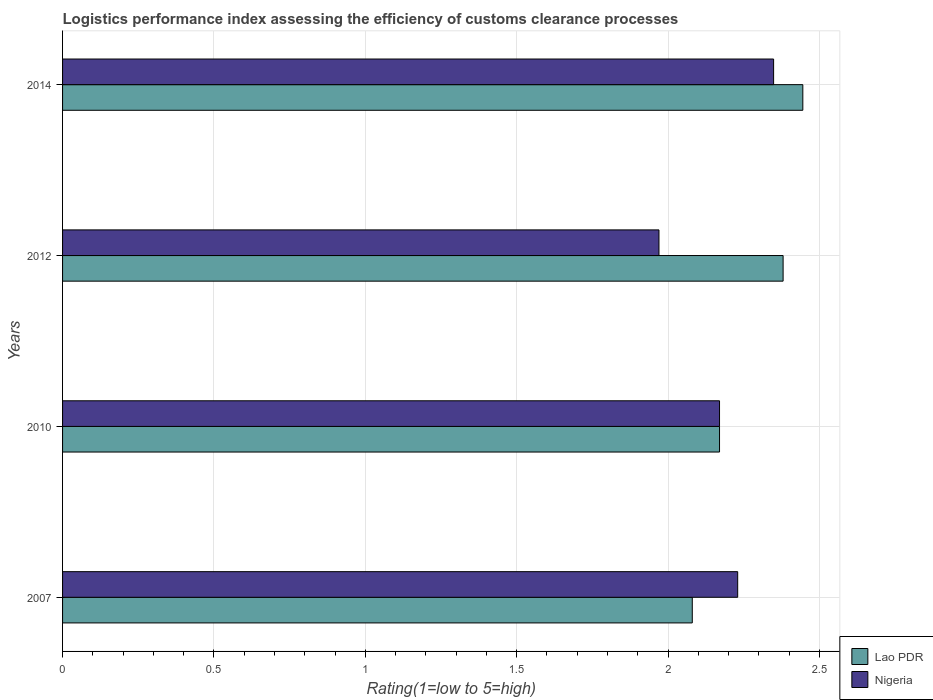How many different coloured bars are there?
Offer a terse response. 2. Are the number of bars per tick equal to the number of legend labels?
Offer a very short reply. Yes. Are the number of bars on each tick of the Y-axis equal?
Your answer should be compact. Yes. How many bars are there on the 1st tick from the top?
Offer a very short reply. 2. How many bars are there on the 2nd tick from the bottom?
Your response must be concise. 2. In how many cases, is the number of bars for a given year not equal to the number of legend labels?
Provide a short and direct response. 0. What is the Logistic performance index in Lao PDR in 2007?
Make the answer very short. 2.08. Across all years, what is the maximum Logistic performance index in Nigeria?
Your answer should be compact. 2.35. Across all years, what is the minimum Logistic performance index in Lao PDR?
Your answer should be compact. 2.08. In which year was the Logistic performance index in Nigeria minimum?
Provide a short and direct response. 2012. What is the total Logistic performance index in Lao PDR in the graph?
Give a very brief answer. 9.08. What is the difference between the Logistic performance index in Nigeria in 2007 and that in 2012?
Keep it short and to the point. 0.26. What is the difference between the Logistic performance index in Lao PDR in 2010 and the Logistic performance index in Nigeria in 2014?
Your answer should be compact. -0.18. What is the average Logistic performance index in Nigeria per year?
Provide a short and direct response. 2.18. In the year 2012, what is the difference between the Logistic performance index in Nigeria and Logistic performance index in Lao PDR?
Keep it short and to the point. -0.41. What is the ratio of the Logistic performance index in Lao PDR in 2007 to that in 2012?
Your answer should be very brief. 0.87. Is the Logistic performance index in Lao PDR in 2012 less than that in 2014?
Give a very brief answer. Yes. Is the difference between the Logistic performance index in Nigeria in 2010 and 2012 greater than the difference between the Logistic performance index in Lao PDR in 2010 and 2012?
Provide a succinct answer. Yes. What is the difference between the highest and the second highest Logistic performance index in Lao PDR?
Offer a very short reply. 0.07. What is the difference between the highest and the lowest Logistic performance index in Nigeria?
Offer a terse response. 0.38. What does the 1st bar from the top in 2010 represents?
Your answer should be very brief. Nigeria. What does the 1st bar from the bottom in 2012 represents?
Provide a short and direct response. Lao PDR. How many bars are there?
Ensure brevity in your answer.  8. Are all the bars in the graph horizontal?
Your response must be concise. Yes. How many years are there in the graph?
Your answer should be very brief. 4. Are the values on the major ticks of X-axis written in scientific E-notation?
Your answer should be very brief. No. Does the graph contain any zero values?
Offer a terse response. No. Does the graph contain grids?
Your answer should be very brief. Yes. Where does the legend appear in the graph?
Keep it short and to the point. Bottom right. How many legend labels are there?
Provide a succinct answer. 2. How are the legend labels stacked?
Your answer should be compact. Vertical. What is the title of the graph?
Offer a terse response. Logistics performance index assessing the efficiency of customs clearance processes. What is the label or title of the X-axis?
Give a very brief answer. Rating(1=low to 5=high). What is the label or title of the Y-axis?
Offer a terse response. Years. What is the Rating(1=low to 5=high) in Lao PDR in 2007?
Your answer should be very brief. 2.08. What is the Rating(1=low to 5=high) of Nigeria in 2007?
Make the answer very short. 2.23. What is the Rating(1=low to 5=high) of Lao PDR in 2010?
Make the answer very short. 2.17. What is the Rating(1=low to 5=high) in Nigeria in 2010?
Ensure brevity in your answer.  2.17. What is the Rating(1=low to 5=high) of Lao PDR in 2012?
Your answer should be very brief. 2.38. What is the Rating(1=low to 5=high) of Nigeria in 2012?
Provide a succinct answer. 1.97. What is the Rating(1=low to 5=high) in Lao PDR in 2014?
Provide a short and direct response. 2.45. What is the Rating(1=low to 5=high) of Nigeria in 2014?
Make the answer very short. 2.35. Across all years, what is the maximum Rating(1=low to 5=high) in Lao PDR?
Provide a succinct answer. 2.45. Across all years, what is the maximum Rating(1=low to 5=high) in Nigeria?
Offer a terse response. 2.35. Across all years, what is the minimum Rating(1=low to 5=high) in Lao PDR?
Keep it short and to the point. 2.08. Across all years, what is the minimum Rating(1=low to 5=high) in Nigeria?
Your answer should be compact. 1.97. What is the total Rating(1=low to 5=high) in Lao PDR in the graph?
Offer a terse response. 9.08. What is the total Rating(1=low to 5=high) of Nigeria in the graph?
Offer a very short reply. 8.72. What is the difference between the Rating(1=low to 5=high) of Lao PDR in 2007 and that in 2010?
Offer a very short reply. -0.09. What is the difference between the Rating(1=low to 5=high) of Lao PDR in 2007 and that in 2012?
Provide a succinct answer. -0.3. What is the difference between the Rating(1=low to 5=high) of Nigeria in 2007 and that in 2012?
Keep it short and to the point. 0.26. What is the difference between the Rating(1=low to 5=high) in Lao PDR in 2007 and that in 2014?
Make the answer very short. -0.37. What is the difference between the Rating(1=low to 5=high) of Nigeria in 2007 and that in 2014?
Your response must be concise. -0.12. What is the difference between the Rating(1=low to 5=high) of Lao PDR in 2010 and that in 2012?
Your answer should be compact. -0.21. What is the difference between the Rating(1=low to 5=high) of Nigeria in 2010 and that in 2012?
Give a very brief answer. 0.2. What is the difference between the Rating(1=low to 5=high) of Lao PDR in 2010 and that in 2014?
Provide a short and direct response. -0.28. What is the difference between the Rating(1=low to 5=high) of Nigeria in 2010 and that in 2014?
Offer a terse response. -0.18. What is the difference between the Rating(1=low to 5=high) in Lao PDR in 2012 and that in 2014?
Provide a succinct answer. -0.07. What is the difference between the Rating(1=low to 5=high) of Nigeria in 2012 and that in 2014?
Keep it short and to the point. -0.38. What is the difference between the Rating(1=low to 5=high) in Lao PDR in 2007 and the Rating(1=low to 5=high) in Nigeria in 2010?
Your answer should be compact. -0.09. What is the difference between the Rating(1=low to 5=high) in Lao PDR in 2007 and the Rating(1=low to 5=high) in Nigeria in 2012?
Your response must be concise. 0.11. What is the difference between the Rating(1=low to 5=high) in Lao PDR in 2007 and the Rating(1=low to 5=high) in Nigeria in 2014?
Offer a terse response. -0.27. What is the difference between the Rating(1=low to 5=high) of Lao PDR in 2010 and the Rating(1=low to 5=high) of Nigeria in 2014?
Make the answer very short. -0.18. What is the difference between the Rating(1=low to 5=high) in Lao PDR in 2012 and the Rating(1=low to 5=high) in Nigeria in 2014?
Your answer should be compact. 0.03. What is the average Rating(1=low to 5=high) of Lao PDR per year?
Your answer should be very brief. 2.27. What is the average Rating(1=low to 5=high) in Nigeria per year?
Offer a very short reply. 2.18. In the year 2010, what is the difference between the Rating(1=low to 5=high) in Lao PDR and Rating(1=low to 5=high) in Nigeria?
Your answer should be very brief. 0. In the year 2012, what is the difference between the Rating(1=low to 5=high) in Lao PDR and Rating(1=low to 5=high) in Nigeria?
Ensure brevity in your answer.  0.41. In the year 2014, what is the difference between the Rating(1=low to 5=high) of Lao PDR and Rating(1=low to 5=high) of Nigeria?
Offer a very short reply. 0.1. What is the ratio of the Rating(1=low to 5=high) of Lao PDR in 2007 to that in 2010?
Your answer should be very brief. 0.96. What is the ratio of the Rating(1=low to 5=high) of Nigeria in 2007 to that in 2010?
Your answer should be compact. 1.03. What is the ratio of the Rating(1=low to 5=high) of Lao PDR in 2007 to that in 2012?
Offer a terse response. 0.87. What is the ratio of the Rating(1=low to 5=high) of Nigeria in 2007 to that in 2012?
Make the answer very short. 1.13. What is the ratio of the Rating(1=low to 5=high) in Lao PDR in 2007 to that in 2014?
Your answer should be compact. 0.85. What is the ratio of the Rating(1=low to 5=high) of Nigeria in 2007 to that in 2014?
Offer a terse response. 0.95. What is the ratio of the Rating(1=low to 5=high) in Lao PDR in 2010 to that in 2012?
Your response must be concise. 0.91. What is the ratio of the Rating(1=low to 5=high) of Nigeria in 2010 to that in 2012?
Provide a succinct answer. 1.1. What is the ratio of the Rating(1=low to 5=high) of Lao PDR in 2010 to that in 2014?
Your answer should be compact. 0.89. What is the ratio of the Rating(1=low to 5=high) of Nigeria in 2010 to that in 2014?
Your answer should be compact. 0.92. What is the ratio of the Rating(1=low to 5=high) in Lao PDR in 2012 to that in 2014?
Your response must be concise. 0.97. What is the ratio of the Rating(1=low to 5=high) of Nigeria in 2012 to that in 2014?
Provide a succinct answer. 0.84. What is the difference between the highest and the second highest Rating(1=low to 5=high) of Lao PDR?
Ensure brevity in your answer.  0.07. What is the difference between the highest and the second highest Rating(1=low to 5=high) of Nigeria?
Provide a succinct answer. 0.12. What is the difference between the highest and the lowest Rating(1=low to 5=high) in Lao PDR?
Provide a short and direct response. 0.37. What is the difference between the highest and the lowest Rating(1=low to 5=high) of Nigeria?
Offer a very short reply. 0.38. 